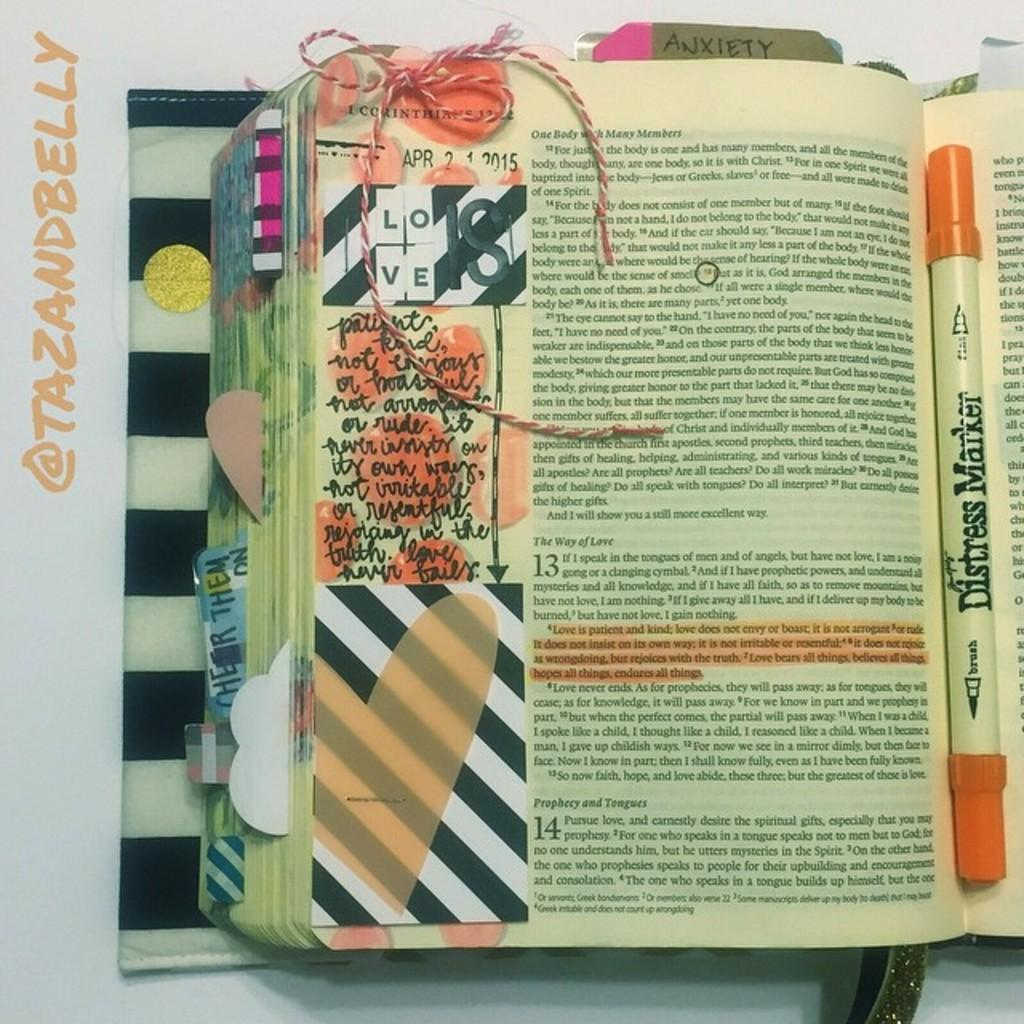<image>
Render a clear and concise summary of the photo. A bible with a highlighter pen in it has a book mark labeled Anxiety. 